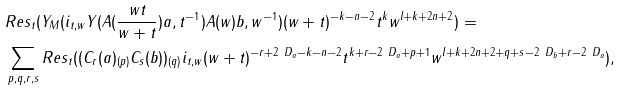Convert formula to latex. <formula><loc_0><loc_0><loc_500><loc_500>& R e s _ { t } ( Y _ { M } ( i _ { t , w } Y ( A ( \frac { w t } { w + t } ) a , t ^ { - 1 } ) A ( w ) b , w ^ { - 1 } ) ( w + t ) ^ { - k - n - 2 } t ^ { k } w ^ { l + k + 2 n + 2 } ) = \\ & \sum _ { p , q , r , s } R e s _ { t } ( ( C _ { r } ( a ) _ { ( p ) } C _ { s } ( b ) ) _ { ( q ) } i _ { t , w } ( w + t ) ^ { - r + 2 \ D _ { a } - k - n - 2 } t ^ { k + r - 2 \ D _ { a } + p + 1 } w ^ { l + k + 2 n + 2 + q + s - 2 \ D _ { b } + r - 2 \ D _ { a } } ) ,</formula> 